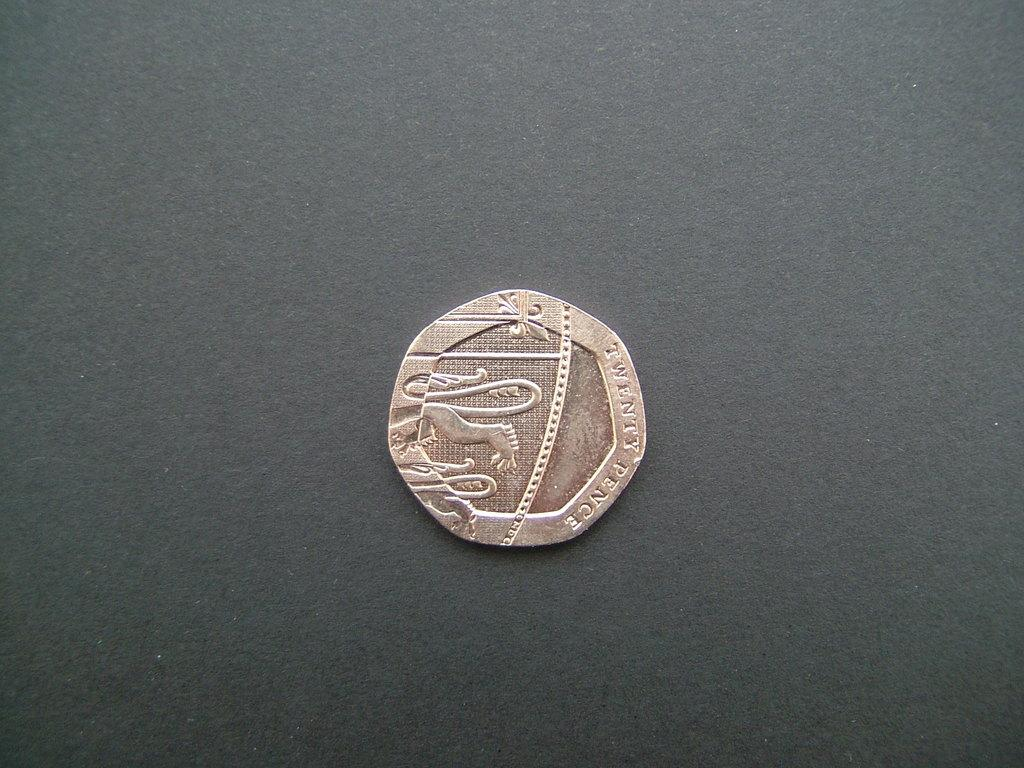Provide a one-sentence caption for the provided image. An old, wooden coin that is brownish in color sits on a black table. 